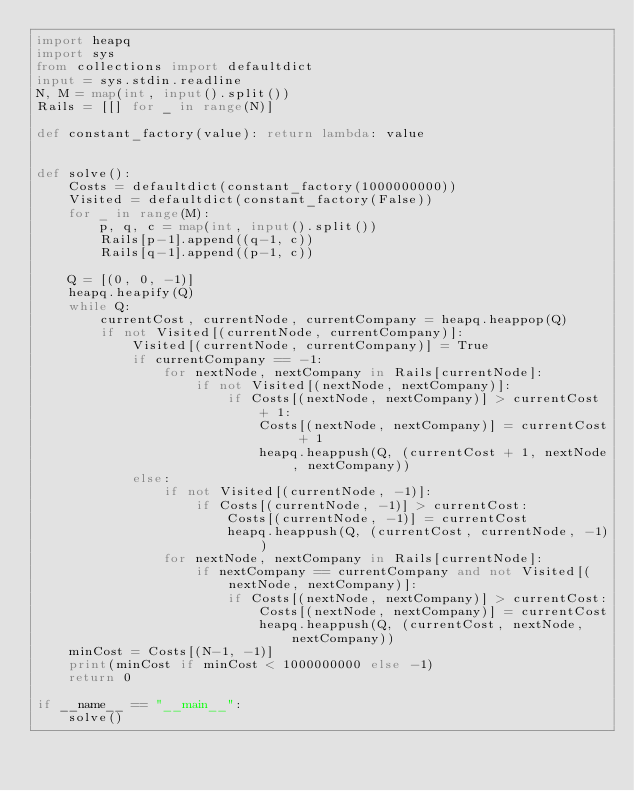<code> <loc_0><loc_0><loc_500><loc_500><_Python_>import heapq
import sys
from collections import defaultdict
input = sys.stdin.readline
N, M = map(int, input().split())
Rails = [[] for _ in range(N)]

def constant_factory(value): return lambda: value


def solve():
    Costs = defaultdict(constant_factory(1000000000))
    Visited = defaultdict(constant_factory(False))
    for _ in range(M):
        p, q, c = map(int, input().split())
        Rails[p-1].append((q-1, c))
        Rails[q-1].append((p-1, c))

    Q = [(0, 0, -1)]
    heapq.heapify(Q)
    while Q:
        currentCost, currentNode, currentCompany = heapq.heappop(Q)
        if not Visited[(currentNode, currentCompany)]:
            Visited[(currentNode, currentCompany)] = True
            if currentCompany == -1:
                for nextNode, nextCompany in Rails[currentNode]:
                    if not Visited[(nextNode, nextCompany)]:
                        if Costs[(nextNode, nextCompany)] > currentCost + 1:
                            Costs[(nextNode, nextCompany)] = currentCost + 1
                            heapq.heappush(Q, (currentCost + 1, nextNode, nextCompany))
            else:
                if not Visited[(currentNode, -1)]:
                    if Costs[(currentNode, -1)] > currentCost:
                        Costs[(currentNode, -1)] = currentCost
                        heapq.heappush(Q, (currentCost, currentNode, -1))
                for nextNode, nextCompany in Rails[currentNode]:
                    if nextCompany == currentCompany and not Visited[(nextNode, nextCompany)]:
                        if Costs[(nextNode, nextCompany)] > currentCost:
                            Costs[(nextNode, nextCompany)] = currentCost
                            heapq.heappush(Q, (currentCost, nextNode, nextCompany))
    minCost = Costs[(N-1, -1)]
    print(minCost if minCost < 1000000000 else -1)
	return 0
  
if __name__ == "__main__":
    solve()</code> 